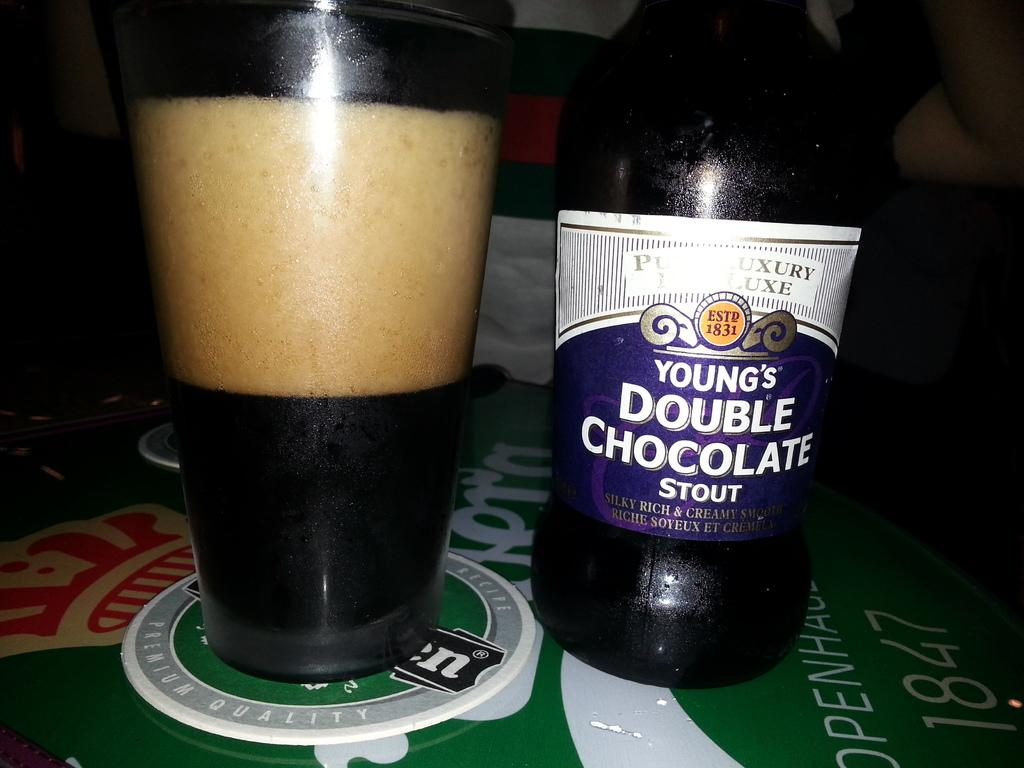<image>
Offer a succinct explanation of the picture presented. A bottle of Young's Double Chocolate Stout is on a table next to a glass. 